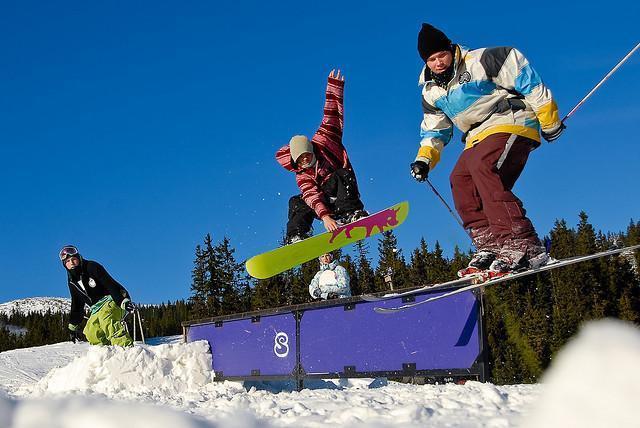How many people are there?
Give a very brief answer. 3. 